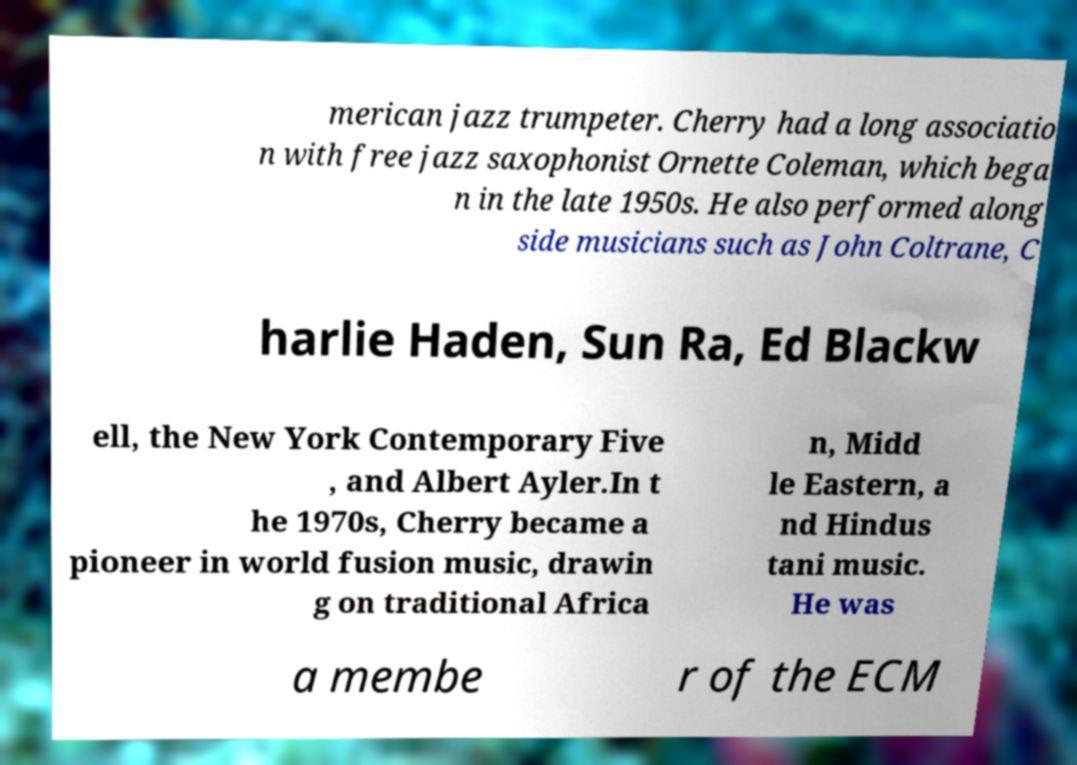For documentation purposes, I need the text within this image transcribed. Could you provide that? merican jazz trumpeter. Cherry had a long associatio n with free jazz saxophonist Ornette Coleman, which bega n in the late 1950s. He also performed along side musicians such as John Coltrane, C harlie Haden, Sun Ra, Ed Blackw ell, the New York Contemporary Five , and Albert Ayler.In t he 1970s, Cherry became a pioneer in world fusion music, drawin g on traditional Africa n, Midd le Eastern, a nd Hindus tani music. He was a membe r of the ECM 